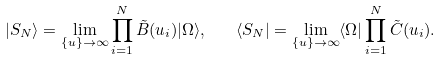<formula> <loc_0><loc_0><loc_500><loc_500>| S _ { N } \rangle = \lim _ { \{ u \} \rightarrow \infty } \prod _ { i = 1 } ^ { N } \tilde { B } ( u _ { i } ) | \Omega \rangle , \quad \langle S _ { N } | = \lim _ { \{ u \} \rightarrow \infty } \langle \Omega | \prod _ { i = 1 } ^ { N } \tilde { C } ( u _ { i } ) .</formula> 